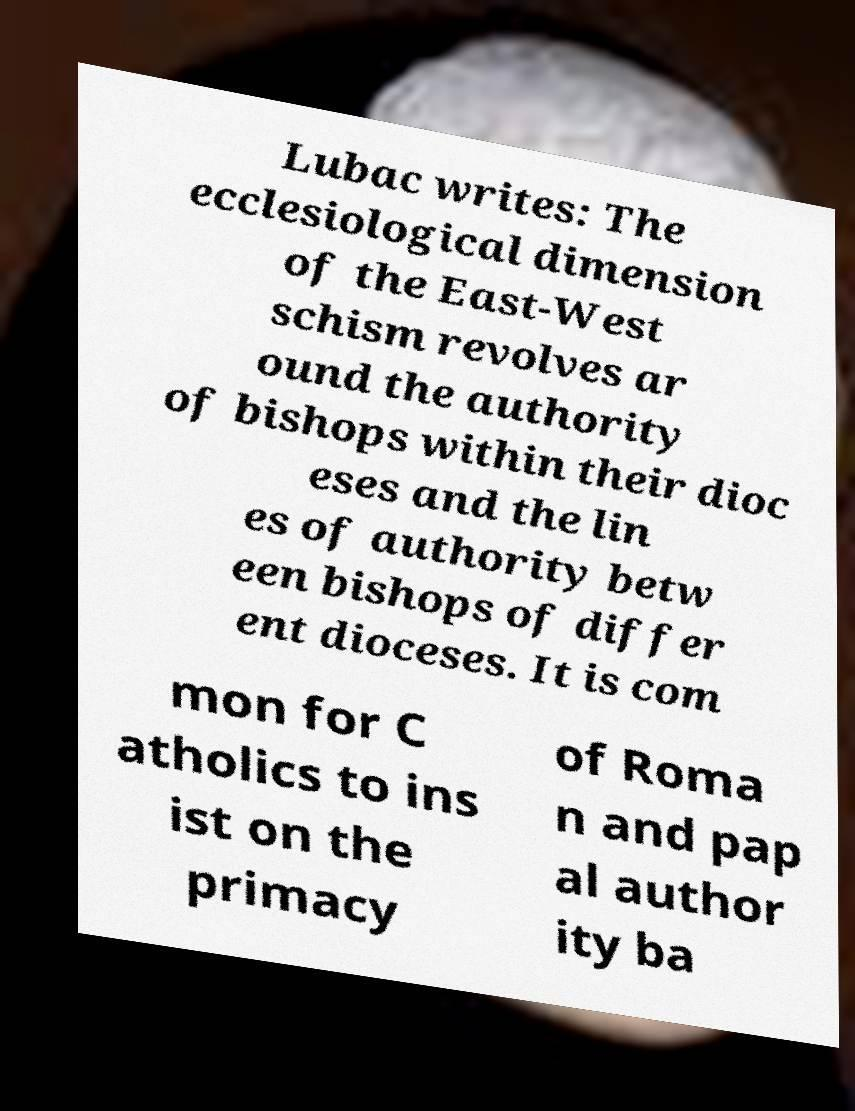Could you extract and type out the text from this image? Lubac writes: The ecclesiological dimension of the East-West schism revolves ar ound the authority of bishops within their dioc eses and the lin es of authority betw een bishops of differ ent dioceses. It is com mon for C atholics to ins ist on the primacy of Roma n and pap al author ity ba 